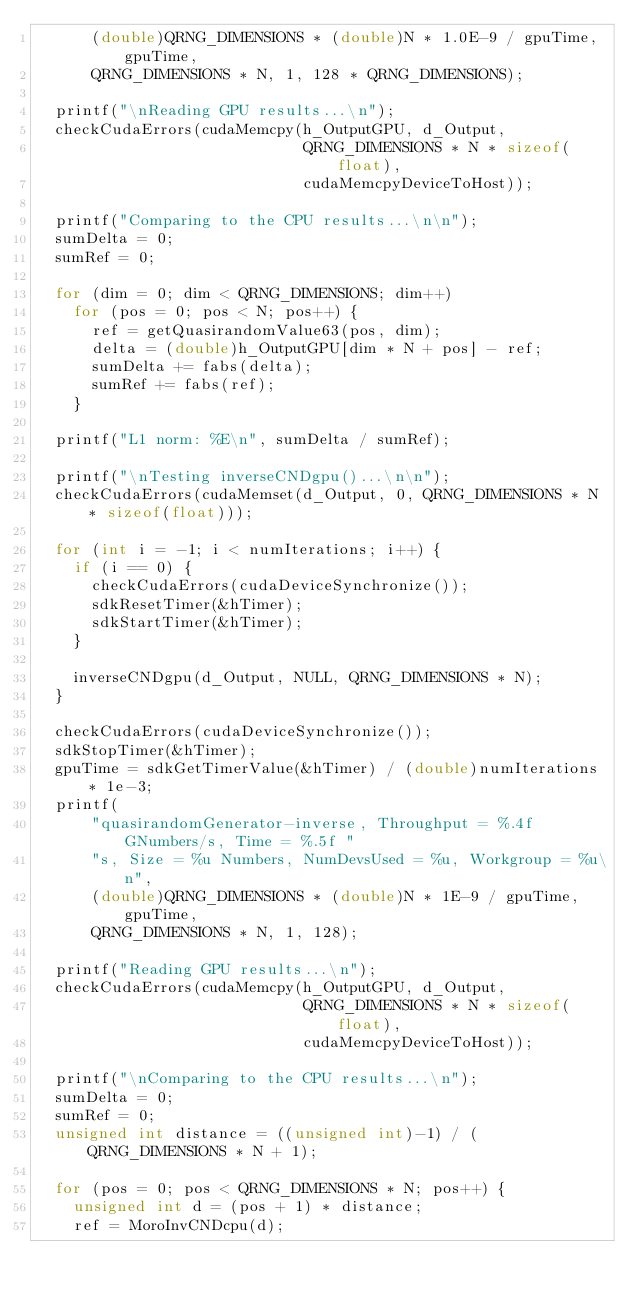<code> <loc_0><loc_0><loc_500><loc_500><_C++_>      (double)QRNG_DIMENSIONS * (double)N * 1.0E-9 / gpuTime, gpuTime,
      QRNG_DIMENSIONS * N, 1, 128 * QRNG_DIMENSIONS);

  printf("\nReading GPU results...\n");
  checkCudaErrors(cudaMemcpy(h_OutputGPU, d_Output,
                             QRNG_DIMENSIONS * N * sizeof(float),
                             cudaMemcpyDeviceToHost));

  printf("Comparing to the CPU results...\n\n");
  sumDelta = 0;
  sumRef = 0;

  for (dim = 0; dim < QRNG_DIMENSIONS; dim++)
    for (pos = 0; pos < N; pos++) {
      ref = getQuasirandomValue63(pos, dim);
      delta = (double)h_OutputGPU[dim * N + pos] - ref;
      sumDelta += fabs(delta);
      sumRef += fabs(ref);
    }

  printf("L1 norm: %E\n", sumDelta / sumRef);

  printf("\nTesting inverseCNDgpu()...\n\n");
  checkCudaErrors(cudaMemset(d_Output, 0, QRNG_DIMENSIONS * N * sizeof(float)));

  for (int i = -1; i < numIterations; i++) {
    if (i == 0) {
      checkCudaErrors(cudaDeviceSynchronize());
      sdkResetTimer(&hTimer);
      sdkStartTimer(&hTimer);
    }

    inverseCNDgpu(d_Output, NULL, QRNG_DIMENSIONS * N);
  }

  checkCudaErrors(cudaDeviceSynchronize());
  sdkStopTimer(&hTimer);
  gpuTime = sdkGetTimerValue(&hTimer) / (double)numIterations * 1e-3;
  printf(
      "quasirandomGenerator-inverse, Throughput = %.4f GNumbers/s, Time = %.5f "
      "s, Size = %u Numbers, NumDevsUsed = %u, Workgroup = %u\n",
      (double)QRNG_DIMENSIONS * (double)N * 1E-9 / gpuTime, gpuTime,
      QRNG_DIMENSIONS * N, 1, 128);

  printf("Reading GPU results...\n");
  checkCudaErrors(cudaMemcpy(h_OutputGPU, d_Output,
                             QRNG_DIMENSIONS * N * sizeof(float),
                             cudaMemcpyDeviceToHost));

  printf("\nComparing to the CPU results...\n");
  sumDelta = 0;
  sumRef = 0;
  unsigned int distance = ((unsigned int)-1) / (QRNG_DIMENSIONS * N + 1);

  for (pos = 0; pos < QRNG_DIMENSIONS * N; pos++) {
    unsigned int d = (pos + 1) * distance;
    ref = MoroInvCNDcpu(d);</code> 